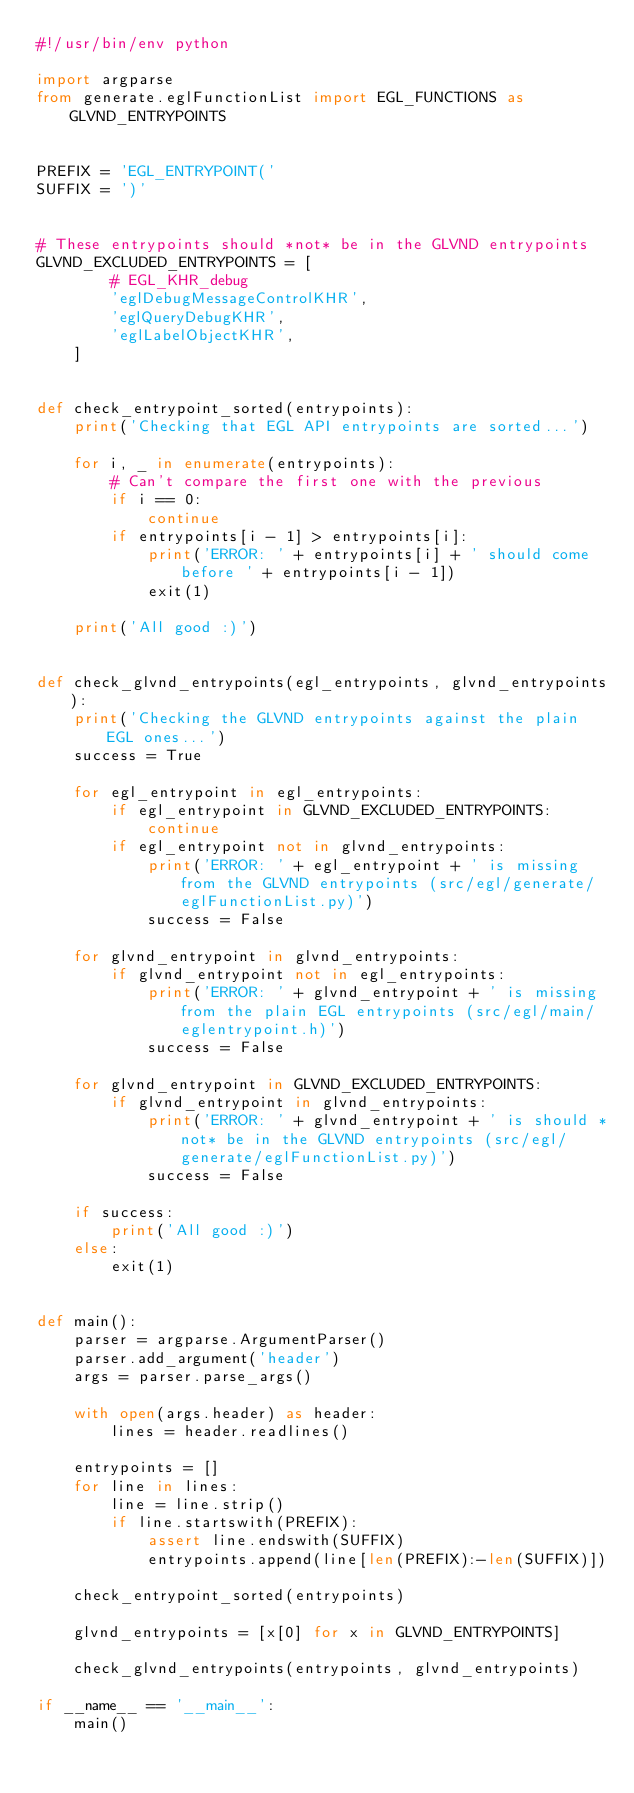Convert code to text. <code><loc_0><loc_0><loc_500><loc_500><_Python_>#!/usr/bin/env python

import argparse
from generate.eglFunctionList import EGL_FUNCTIONS as GLVND_ENTRYPOINTS


PREFIX = 'EGL_ENTRYPOINT('
SUFFIX = ')'


# These entrypoints should *not* be in the GLVND entrypoints
GLVND_EXCLUDED_ENTRYPOINTS = [
        # EGL_KHR_debug
        'eglDebugMessageControlKHR',
        'eglQueryDebugKHR',
        'eglLabelObjectKHR',
    ]


def check_entrypoint_sorted(entrypoints):
    print('Checking that EGL API entrypoints are sorted...')

    for i, _ in enumerate(entrypoints):
        # Can't compare the first one with the previous
        if i == 0:
            continue
        if entrypoints[i - 1] > entrypoints[i]:
            print('ERROR: ' + entrypoints[i] + ' should come before ' + entrypoints[i - 1])
            exit(1)

    print('All good :)')


def check_glvnd_entrypoints(egl_entrypoints, glvnd_entrypoints):
    print('Checking the GLVND entrypoints against the plain EGL ones...')
    success = True

    for egl_entrypoint in egl_entrypoints:
        if egl_entrypoint in GLVND_EXCLUDED_ENTRYPOINTS:
            continue
        if egl_entrypoint not in glvnd_entrypoints:
            print('ERROR: ' + egl_entrypoint + ' is missing from the GLVND entrypoints (src/egl/generate/eglFunctionList.py)')
            success = False

    for glvnd_entrypoint in glvnd_entrypoints:
        if glvnd_entrypoint not in egl_entrypoints:
            print('ERROR: ' + glvnd_entrypoint + ' is missing from the plain EGL entrypoints (src/egl/main/eglentrypoint.h)')
            success = False

    for glvnd_entrypoint in GLVND_EXCLUDED_ENTRYPOINTS:
        if glvnd_entrypoint in glvnd_entrypoints:
            print('ERROR: ' + glvnd_entrypoint + ' is should *not* be in the GLVND entrypoints (src/egl/generate/eglFunctionList.py)')
            success = False

    if success:
        print('All good :)')
    else:
        exit(1)


def main():
    parser = argparse.ArgumentParser()
    parser.add_argument('header')
    args = parser.parse_args()

    with open(args.header) as header:
        lines = header.readlines()

    entrypoints = []
    for line in lines:
        line = line.strip()
        if line.startswith(PREFIX):
            assert line.endswith(SUFFIX)
            entrypoints.append(line[len(PREFIX):-len(SUFFIX)])

    check_entrypoint_sorted(entrypoints)

    glvnd_entrypoints = [x[0] for x in GLVND_ENTRYPOINTS]

    check_glvnd_entrypoints(entrypoints, glvnd_entrypoints)

if __name__ == '__main__':
    main()
</code> 